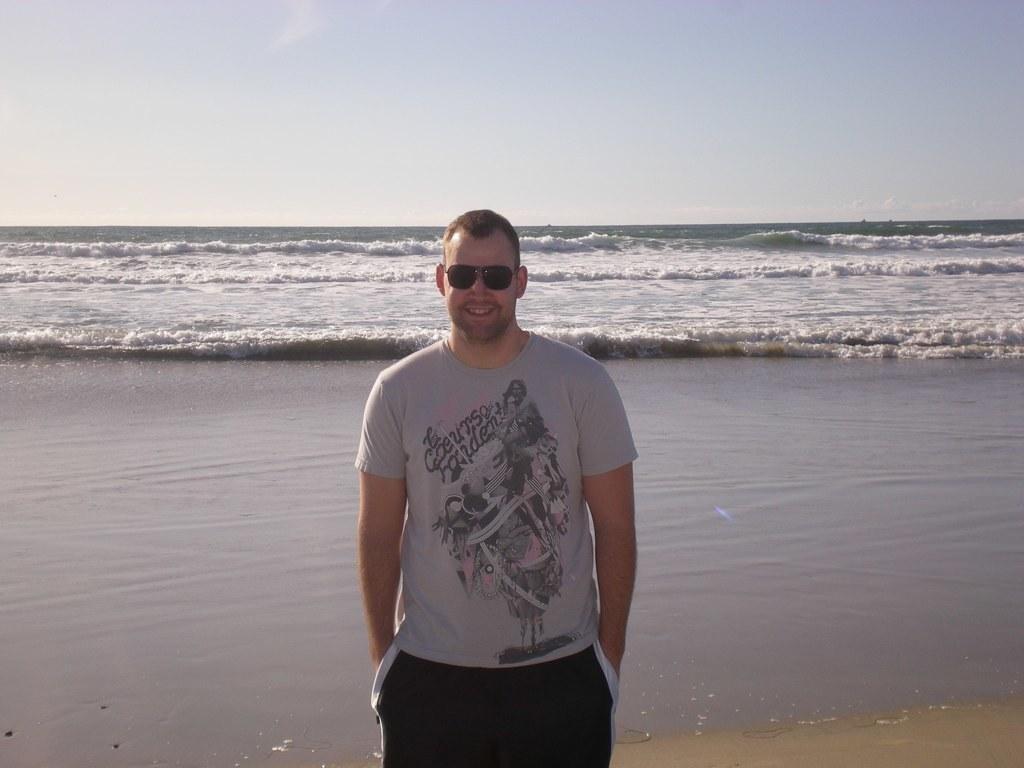How would you summarize this image in a sentence or two? In this image, we can see a person is standing and smiling. He is wearing goggles. Background we can see water waves and sky. 